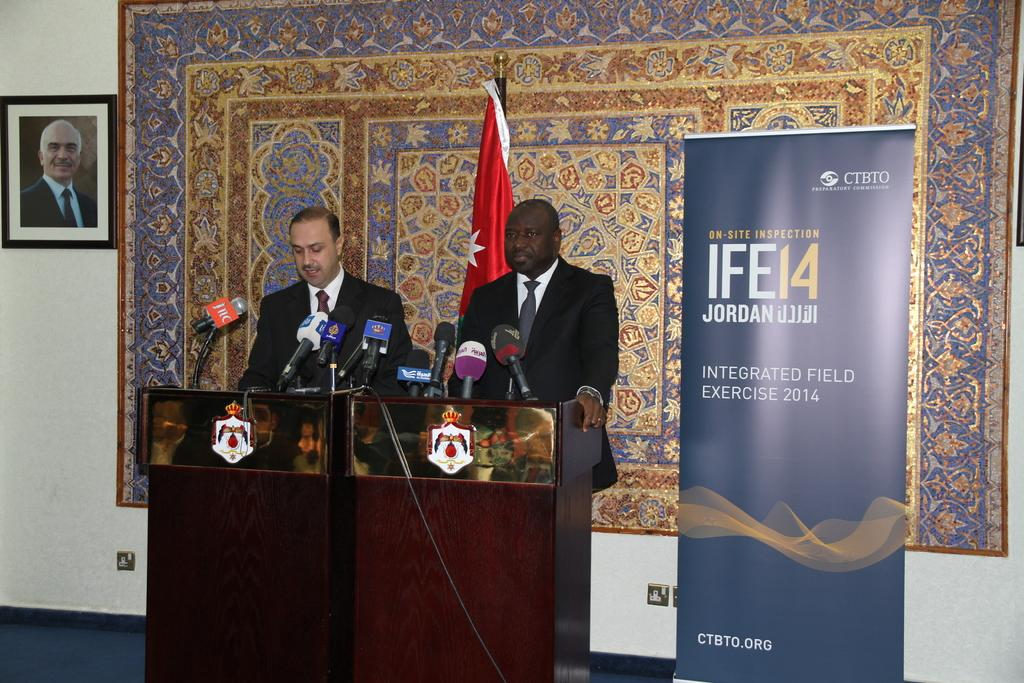<image>
Relay a brief, clear account of the picture shown. Two men standing at a podium for the IFE14. 